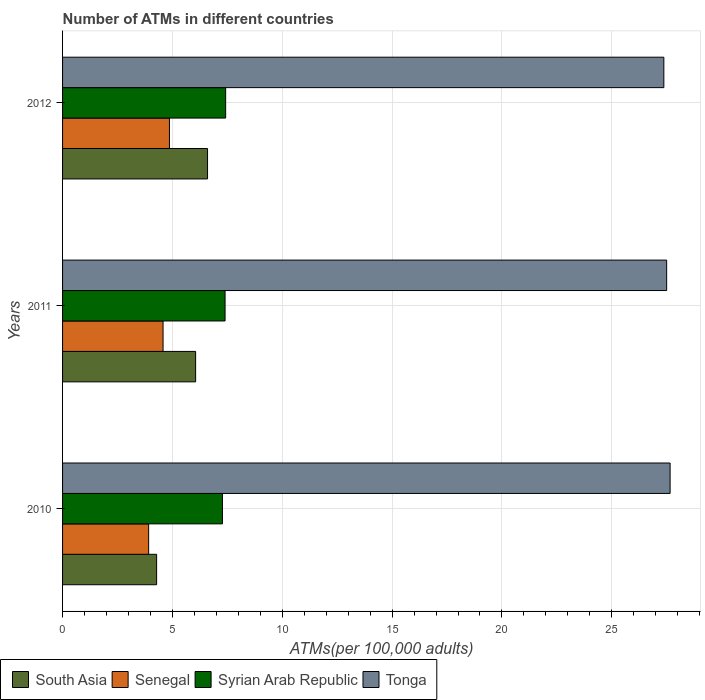Are the number of bars per tick equal to the number of legend labels?
Ensure brevity in your answer.  Yes. How many bars are there on the 1st tick from the top?
Provide a succinct answer. 4. How many bars are there on the 2nd tick from the bottom?
Make the answer very short. 4. What is the label of the 1st group of bars from the top?
Provide a short and direct response. 2012. What is the number of ATMs in Tonga in 2012?
Make the answer very short. 27.37. Across all years, what is the maximum number of ATMs in Senegal?
Provide a short and direct response. 4.86. Across all years, what is the minimum number of ATMs in Senegal?
Provide a short and direct response. 3.92. What is the total number of ATMs in Senegal in the graph?
Keep it short and to the point. 13.36. What is the difference between the number of ATMs in South Asia in 2010 and that in 2012?
Your response must be concise. -2.32. What is the difference between the number of ATMs in Tonga in 2010 and the number of ATMs in South Asia in 2012?
Provide a succinct answer. 21.06. What is the average number of ATMs in Syrian Arab Republic per year?
Keep it short and to the point. 7.37. In the year 2010, what is the difference between the number of ATMs in Tonga and number of ATMs in South Asia?
Your answer should be compact. 23.37. In how many years, is the number of ATMs in Tonga greater than 20 ?
Give a very brief answer. 3. What is the ratio of the number of ATMs in Syrian Arab Republic in 2010 to that in 2011?
Make the answer very short. 0.98. What is the difference between the highest and the second highest number of ATMs in South Asia?
Offer a very short reply. 0.54. What is the difference between the highest and the lowest number of ATMs in Senegal?
Your answer should be very brief. 0.95. Is it the case that in every year, the sum of the number of ATMs in Tonga and number of ATMs in Syrian Arab Republic is greater than the sum of number of ATMs in South Asia and number of ATMs in Senegal?
Ensure brevity in your answer.  Yes. What does the 3rd bar from the top in 2011 represents?
Offer a very short reply. Senegal. What does the 3rd bar from the bottom in 2011 represents?
Provide a short and direct response. Syrian Arab Republic. How many bars are there?
Keep it short and to the point. 12. Are all the bars in the graph horizontal?
Provide a short and direct response. Yes. How many years are there in the graph?
Your answer should be very brief. 3. What is the difference between two consecutive major ticks on the X-axis?
Offer a very short reply. 5. Are the values on the major ticks of X-axis written in scientific E-notation?
Your answer should be very brief. No. How many legend labels are there?
Offer a very short reply. 4. How are the legend labels stacked?
Keep it short and to the point. Horizontal. What is the title of the graph?
Keep it short and to the point. Number of ATMs in different countries. What is the label or title of the X-axis?
Provide a succinct answer. ATMs(per 100,0 adults). What is the ATMs(per 100,000 adults) in South Asia in 2010?
Give a very brief answer. 4.28. What is the ATMs(per 100,000 adults) of Senegal in 2010?
Make the answer very short. 3.92. What is the ATMs(per 100,000 adults) in Syrian Arab Republic in 2010?
Your answer should be compact. 7.28. What is the ATMs(per 100,000 adults) in Tonga in 2010?
Your response must be concise. 27.65. What is the ATMs(per 100,000 adults) in South Asia in 2011?
Ensure brevity in your answer.  6.06. What is the ATMs(per 100,000 adults) in Senegal in 2011?
Provide a short and direct response. 4.57. What is the ATMs(per 100,000 adults) in Syrian Arab Republic in 2011?
Your response must be concise. 7.4. What is the ATMs(per 100,000 adults) of Tonga in 2011?
Your answer should be compact. 27.5. What is the ATMs(per 100,000 adults) of South Asia in 2012?
Offer a terse response. 6.6. What is the ATMs(per 100,000 adults) of Senegal in 2012?
Provide a short and direct response. 4.86. What is the ATMs(per 100,000 adults) of Syrian Arab Republic in 2012?
Give a very brief answer. 7.42. What is the ATMs(per 100,000 adults) of Tonga in 2012?
Offer a terse response. 27.37. Across all years, what is the maximum ATMs(per 100,000 adults) in South Asia?
Your answer should be very brief. 6.6. Across all years, what is the maximum ATMs(per 100,000 adults) of Senegal?
Provide a short and direct response. 4.86. Across all years, what is the maximum ATMs(per 100,000 adults) of Syrian Arab Republic?
Provide a short and direct response. 7.42. Across all years, what is the maximum ATMs(per 100,000 adults) in Tonga?
Offer a very short reply. 27.65. Across all years, what is the minimum ATMs(per 100,000 adults) in South Asia?
Your answer should be very brief. 4.28. Across all years, what is the minimum ATMs(per 100,000 adults) in Senegal?
Your answer should be compact. 3.92. Across all years, what is the minimum ATMs(per 100,000 adults) in Syrian Arab Republic?
Offer a very short reply. 7.28. Across all years, what is the minimum ATMs(per 100,000 adults) in Tonga?
Provide a short and direct response. 27.37. What is the total ATMs(per 100,000 adults) of South Asia in the graph?
Make the answer very short. 16.94. What is the total ATMs(per 100,000 adults) of Senegal in the graph?
Your response must be concise. 13.36. What is the total ATMs(per 100,000 adults) of Syrian Arab Republic in the graph?
Your answer should be compact. 22.1. What is the total ATMs(per 100,000 adults) in Tonga in the graph?
Your answer should be compact. 82.52. What is the difference between the ATMs(per 100,000 adults) of South Asia in 2010 and that in 2011?
Offer a terse response. -1.78. What is the difference between the ATMs(per 100,000 adults) in Senegal in 2010 and that in 2011?
Provide a short and direct response. -0.66. What is the difference between the ATMs(per 100,000 adults) in Syrian Arab Republic in 2010 and that in 2011?
Offer a very short reply. -0.12. What is the difference between the ATMs(per 100,000 adults) in Tonga in 2010 and that in 2011?
Ensure brevity in your answer.  0.16. What is the difference between the ATMs(per 100,000 adults) in South Asia in 2010 and that in 2012?
Give a very brief answer. -2.32. What is the difference between the ATMs(per 100,000 adults) in Senegal in 2010 and that in 2012?
Provide a short and direct response. -0.95. What is the difference between the ATMs(per 100,000 adults) of Syrian Arab Republic in 2010 and that in 2012?
Make the answer very short. -0.15. What is the difference between the ATMs(per 100,000 adults) in Tonga in 2010 and that in 2012?
Provide a short and direct response. 0.29. What is the difference between the ATMs(per 100,000 adults) of South Asia in 2011 and that in 2012?
Ensure brevity in your answer.  -0.54. What is the difference between the ATMs(per 100,000 adults) of Senegal in 2011 and that in 2012?
Keep it short and to the point. -0.29. What is the difference between the ATMs(per 100,000 adults) of Syrian Arab Republic in 2011 and that in 2012?
Provide a short and direct response. -0.03. What is the difference between the ATMs(per 100,000 adults) in Tonga in 2011 and that in 2012?
Make the answer very short. 0.13. What is the difference between the ATMs(per 100,000 adults) of South Asia in 2010 and the ATMs(per 100,000 adults) of Senegal in 2011?
Offer a very short reply. -0.29. What is the difference between the ATMs(per 100,000 adults) in South Asia in 2010 and the ATMs(per 100,000 adults) in Syrian Arab Republic in 2011?
Offer a terse response. -3.12. What is the difference between the ATMs(per 100,000 adults) in South Asia in 2010 and the ATMs(per 100,000 adults) in Tonga in 2011?
Make the answer very short. -23.22. What is the difference between the ATMs(per 100,000 adults) in Senegal in 2010 and the ATMs(per 100,000 adults) in Syrian Arab Republic in 2011?
Provide a short and direct response. -3.48. What is the difference between the ATMs(per 100,000 adults) in Senegal in 2010 and the ATMs(per 100,000 adults) in Tonga in 2011?
Offer a very short reply. -23.58. What is the difference between the ATMs(per 100,000 adults) in Syrian Arab Republic in 2010 and the ATMs(per 100,000 adults) in Tonga in 2011?
Offer a very short reply. -20.22. What is the difference between the ATMs(per 100,000 adults) in South Asia in 2010 and the ATMs(per 100,000 adults) in Senegal in 2012?
Your answer should be very brief. -0.58. What is the difference between the ATMs(per 100,000 adults) in South Asia in 2010 and the ATMs(per 100,000 adults) in Syrian Arab Republic in 2012?
Offer a very short reply. -3.14. What is the difference between the ATMs(per 100,000 adults) of South Asia in 2010 and the ATMs(per 100,000 adults) of Tonga in 2012?
Offer a terse response. -23.09. What is the difference between the ATMs(per 100,000 adults) in Senegal in 2010 and the ATMs(per 100,000 adults) in Syrian Arab Republic in 2012?
Offer a terse response. -3.51. What is the difference between the ATMs(per 100,000 adults) of Senegal in 2010 and the ATMs(per 100,000 adults) of Tonga in 2012?
Provide a short and direct response. -23.45. What is the difference between the ATMs(per 100,000 adults) in Syrian Arab Republic in 2010 and the ATMs(per 100,000 adults) in Tonga in 2012?
Your answer should be compact. -20.09. What is the difference between the ATMs(per 100,000 adults) in South Asia in 2011 and the ATMs(per 100,000 adults) in Senegal in 2012?
Give a very brief answer. 1.19. What is the difference between the ATMs(per 100,000 adults) of South Asia in 2011 and the ATMs(per 100,000 adults) of Syrian Arab Republic in 2012?
Make the answer very short. -1.37. What is the difference between the ATMs(per 100,000 adults) in South Asia in 2011 and the ATMs(per 100,000 adults) in Tonga in 2012?
Give a very brief answer. -21.31. What is the difference between the ATMs(per 100,000 adults) of Senegal in 2011 and the ATMs(per 100,000 adults) of Syrian Arab Republic in 2012?
Offer a terse response. -2.85. What is the difference between the ATMs(per 100,000 adults) in Senegal in 2011 and the ATMs(per 100,000 adults) in Tonga in 2012?
Provide a succinct answer. -22.8. What is the difference between the ATMs(per 100,000 adults) in Syrian Arab Republic in 2011 and the ATMs(per 100,000 adults) in Tonga in 2012?
Provide a short and direct response. -19.97. What is the average ATMs(per 100,000 adults) of South Asia per year?
Make the answer very short. 5.65. What is the average ATMs(per 100,000 adults) of Senegal per year?
Your answer should be compact. 4.45. What is the average ATMs(per 100,000 adults) of Syrian Arab Republic per year?
Your answer should be very brief. 7.37. What is the average ATMs(per 100,000 adults) in Tonga per year?
Keep it short and to the point. 27.51. In the year 2010, what is the difference between the ATMs(per 100,000 adults) of South Asia and ATMs(per 100,000 adults) of Senegal?
Ensure brevity in your answer.  0.36. In the year 2010, what is the difference between the ATMs(per 100,000 adults) of South Asia and ATMs(per 100,000 adults) of Syrian Arab Republic?
Make the answer very short. -3. In the year 2010, what is the difference between the ATMs(per 100,000 adults) of South Asia and ATMs(per 100,000 adults) of Tonga?
Provide a short and direct response. -23.37. In the year 2010, what is the difference between the ATMs(per 100,000 adults) in Senegal and ATMs(per 100,000 adults) in Syrian Arab Republic?
Keep it short and to the point. -3.36. In the year 2010, what is the difference between the ATMs(per 100,000 adults) of Senegal and ATMs(per 100,000 adults) of Tonga?
Give a very brief answer. -23.74. In the year 2010, what is the difference between the ATMs(per 100,000 adults) in Syrian Arab Republic and ATMs(per 100,000 adults) in Tonga?
Keep it short and to the point. -20.38. In the year 2011, what is the difference between the ATMs(per 100,000 adults) in South Asia and ATMs(per 100,000 adults) in Senegal?
Your answer should be very brief. 1.48. In the year 2011, what is the difference between the ATMs(per 100,000 adults) in South Asia and ATMs(per 100,000 adults) in Syrian Arab Republic?
Offer a very short reply. -1.34. In the year 2011, what is the difference between the ATMs(per 100,000 adults) in South Asia and ATMs(per 100,000 adults) in Tonga?
Keep it short and to the point. -21.44. In the year 2011, what is the difference between the ATMs(per 100,000 adults) in Senegal and ATMs(per 100,000 adults) in Syrian Arab Republic?
Offer a terse response. -2.82. In the year 2011, what is the difference between the ATMs(per 100,000 adults) in Senegal and ATMs(per 100,000 adults) in Tonga?
Provide a succinct answer. -22.92. In the year 2011, what is the difference between the ATMs(per 100,000 adults) in Syrian Arab Republic and ATMs(per 100,000 adults) in Tonga?
Your answer should be compact. -20.1. In the year 2012, what is the difference between the ATMs(per 100,000 adults) in South Asia and ATMs(per 100,000 adults) in Senegal?
Your answer should be very brief. 1.73. In the year 2012, what is the difference between the ATMs(per 100,000 adults) in South Asia and ATMs(per 100,000 adults) in Syrian Arab Republic?
Your answer should be compact. -0.82. In the year 2012, what is the difference between the ATMs(per 100,000 adults) in South Asia and ATMs(per 100,000 adults) in Tonga?
Your answer should be compact. -20.77. In the year 2012, what is the difference between the ATMs(per 100,000 adults) of Senegal and ATMs(per 100,000 adults) of Syrian Arab Republic?
Ensure brevity in your answer.  -2.56. In the year 2012, what is the difference between the ATMs(per 100,000 adults) in Senegal and ATMs(per 100,000 adults) in Tonga?
Provide a succinct answer. -22.5. In the year 2012, what is the difference between the ATMs(per 100,000 adults) in Syrian Arab Republic and ATMs(per 100,000 adults) in Tonga?
Keep it short and to the point. -19.95. What is the ratio of the ATMs(per 100,000 adults) in South Asia in 2010 to that in 2011?
Offer a terse response. 0.71. What is the ratio of the ATMs(per 100,000 adults) of Senegal in 2010 to that in 2011?
Provide a short and direct response. 0.86. What is the ratio of the ATMs(per 100,000 adults) of Syrian Arab Republic in 2010 to that in 2011?
Offer a very short reply. 0.98. What is the ratio of the ATMs(per 100,000 adults) of Tonga in 2010 to that in 2011?
Make the answer very short. 1.01. What is the ratio of the ATMs(per 100,000 adults) of South Asia in 2010 to that in 2012?
Provide a succinct answer. 0.65. What is the ratio of the ATMs(per 100,000 adults) in Senegal in 2010 to that in 2012?
Give a very brief answer. 0.81. What is the ratio of the ATMs(per 100,000 adults) of Syrian Arab Republic in 2010 to that in 2012?
Your response must be concise. 0.98. What is the ratio of the ATMs(per 100,000 adults) of Tonga in 2010 to that in 2012?
Give a very brief answer. 1.01. What is the ratio of the ATMs(per 100,000 adults) of South Asia in 2011 to that in 2012?
Offer a very short reply. 0.92. What is the ratio of the ATMs(per 100,000 adults) in Senegal in 2011 to that in 2012?
Your answer should be very brief. 0.94. What is the ratio of the ATMs(per 100,000 adults) of Syrian Arab Republic in 2011 to that in 2012?
Keep it short and to the point. 1. What is the ratio of the ATMs(per 100,000 adults) in Tonga in 2011 to that in 2012?
Keep it short and to the point. 1. What is the difference between the highest and the second highest ATMs(per 100,000 adults) in South Asia?
Make the answer very short. 0.54. What is the difference between the highest and the second highest ATMs(per 100,000 adults) in Senegal?
Give a very brief answer. 0.29. What is the difference between the highest and the second highest ATMs(per 100,000 adults) of Syrian Arab Republic?
Keep it short and to the point. 0.03. What is the difference between the highest and the second highest ATMs(per 100,000 adults) in Tonga?
Your response must be concise. 0.16. What is the difference between the highest and the lowest ATMs(per 100,000 adults) of South Asia?
Your answer should be very brief. 2.32. What is the difference between the highest and the lowest ATMs(per 100,000 adults) of Senegal?
Offer a very short reply. 0.95. What is the difference between the highest and the lowest ATMs(per 100,000 adults) of Syrian Arab Republic?
Your response must be concise. 0.15. What is the difference between the highest and the lowest ATMs(per 100,000 adults) in Tonga?
Keep it short and to the point. 0.29. 